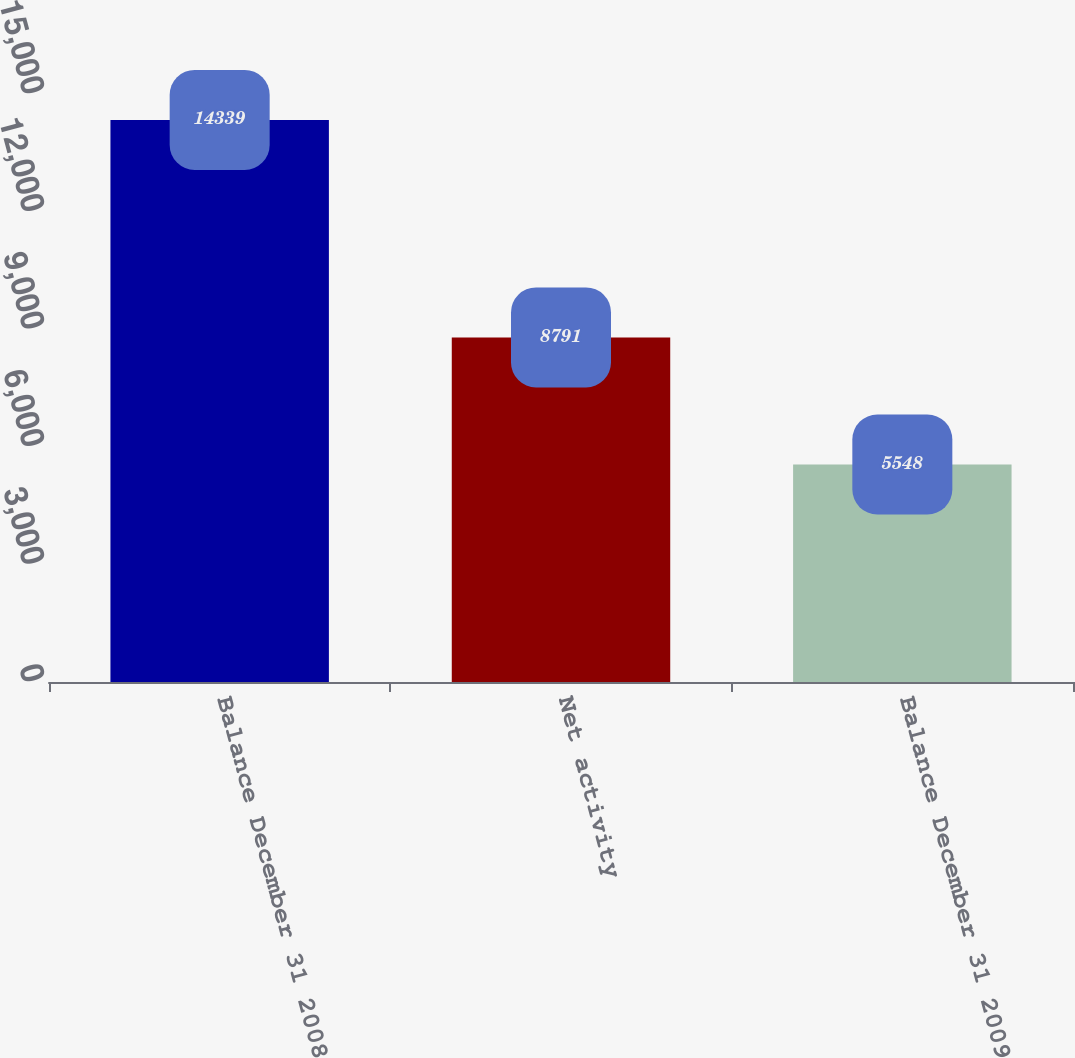Convert chart to OTSL. <chart><loc_0><loc_0><loc_500><loc_500><bar_chart><fcel>Balance December 31 2008<fcel>Net activity<fcel>Balance December 31 2009<nl><fcel>14339<fcel>8791<fcel>5548<nl></chart> 